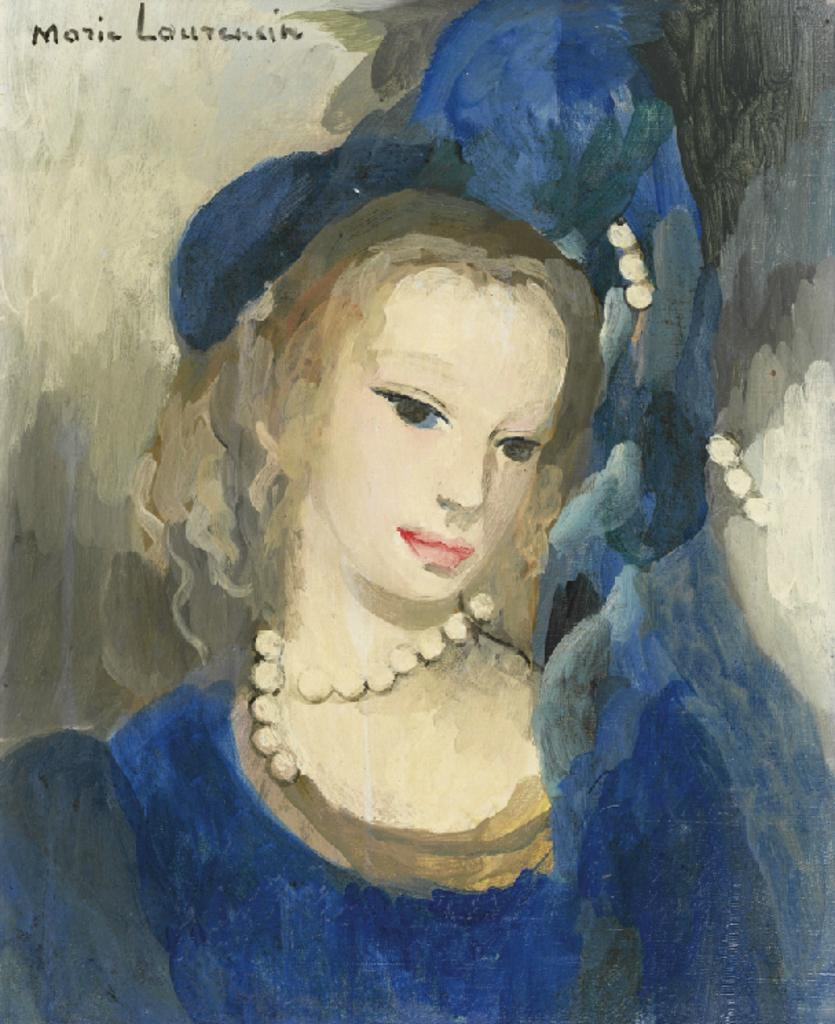What is the main subject of the image? The main subject of the image is a painting. What is the painting depicting? The painting depicts a woman. What else can be seen in the image besides the painting? There is text present in the image. How many chairs are visible in the painting? There are no chairs visible in the painting; it depicts a woman. What type of pot is featured in the painting? There is no pot present in the painting; it depicts a woman. 